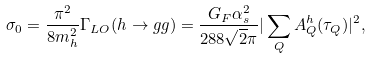<formula> <loc_0><loc_0><loc_500><loc_500>\sigma _ { 0 } = \frac { \pi ^ { 2 } } { 8 m _ { h } ^ { 2 } } \Gamma _ { L O } ( h \rightarrow g g ) = \frac { G _ { F } \alpha _ { s } ^ { 2 } } { 2 8 8 \sqrt { 2 } \pi } | \sum _ { Q } A _ { Q } ^ { h } ( \tau _ { Q } ) | ^ { 2 } ,</formula> 